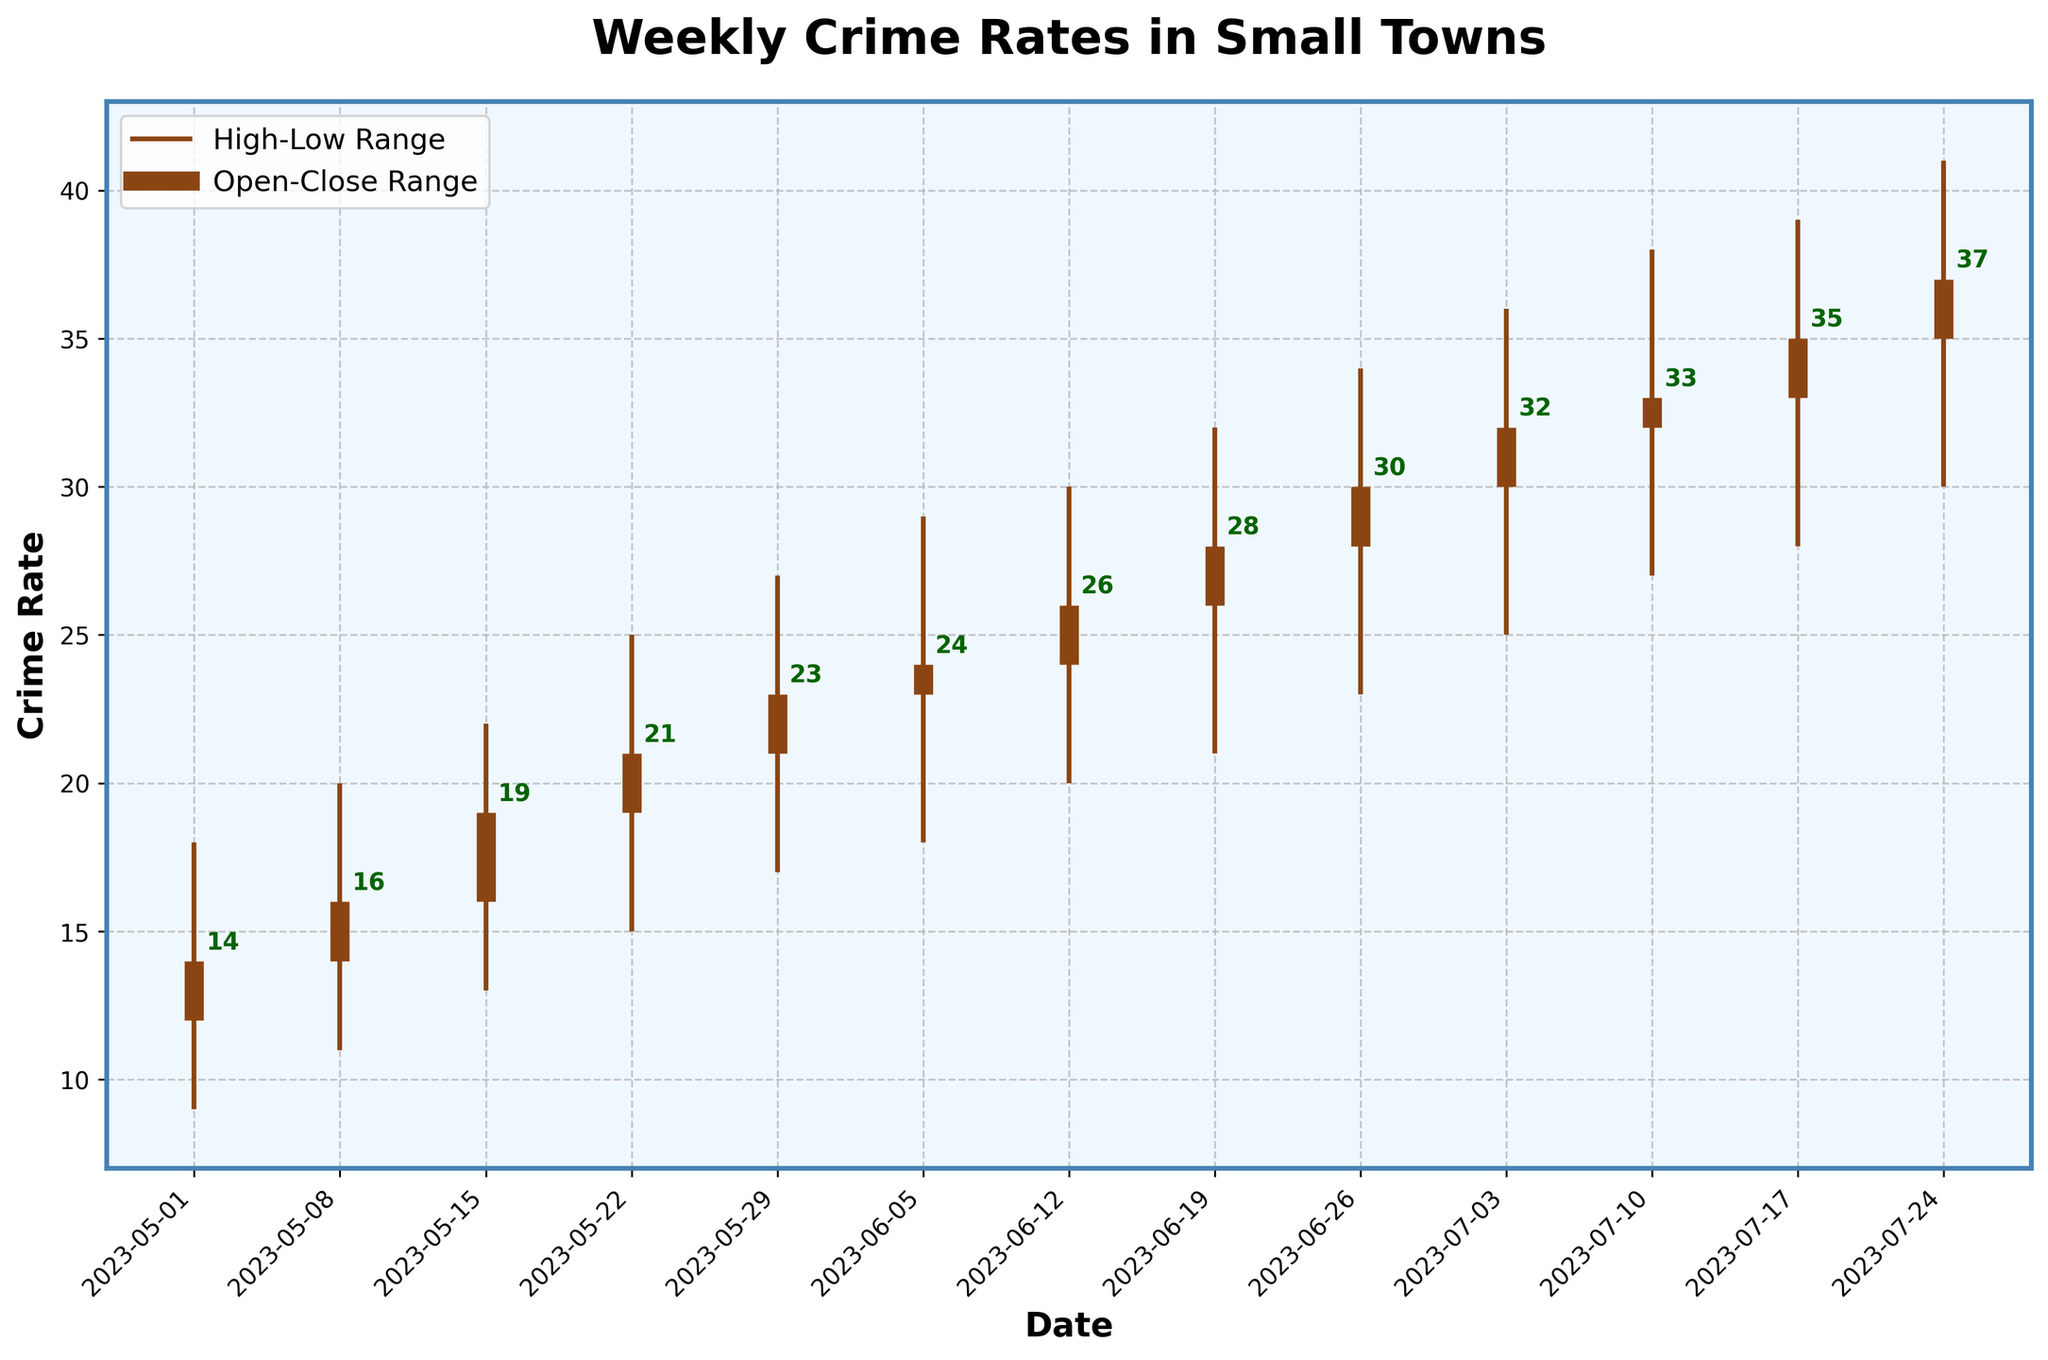what is the title of the plot? The title is displayed at the top of the figure in a prominent font. It indicates the general subject of the figure.
Answer: Weekly Crime Rates in Small Towns Which week had the highest crime rate for the given time period? To find the week with the highest crime rate, we need to look at the 'High' values in the OHLC chart and identify the maximum value.
Answer: Week starting on 2023-07-24 What are the open and close crime rates for the week of May 22nd, 2023? The open and close rates can be found by looking at where the thick vertical lines (bars) start and end for the specific date on the x-axis.
Answer: Open: 19, Close: 21 Between which weeks did the crime rate see the biggest increase in the close value? To find the biggest increase, we need to calculate the difference between close values of consecutive weeks and identify the largest change.
Answer: Between 2023-06-26 (30) and 2023-07-03 (32) What are the minimum and maximum crime rates recorded over the entire period? The minimum and maximum rates are found by identifying the smallest and largest values in the 'Low' and 'High' columns respectively.
Answer: Minimum: 9, Maximum: 41 By how many points did the crime rate change from the open to close in the week of June 12th, 2023? To find the change, we subtract the open value from the close value for the specified week.
Answer: Change: 2 (26 - 24) How did the trend in weekly crime rates change over time? To understand the trend, observe the general direction of the close rates over the weeks. Are they increasing, decreasing or fluctuating?
Answer: The crime rates are generally trending upwards over the period Which week had the smallest difference between its high and low crime rates? The smallest difference is identified by subtracting the low value from the high value for each week and finding the minimum result.
Answer: Week starting on 2023-05-01 (difference of 9) What were the high and low crime rates for the first week of June 2023? The high and low rates for any given week can be found where the thin vertical lines extend the furthest up and down.
Answer: High: 29, Low: 18 Is the crime rate steadily increasing over the observed period? Support your answer with two observations from the plot. To determine if the rate is steadily increasing, observe the open and close values over the given period and look for consistent increases.
Answer: Yes, the open rates mostly increase each week and the close rates follow an increasing trend (e.g., from 12 to 35) 